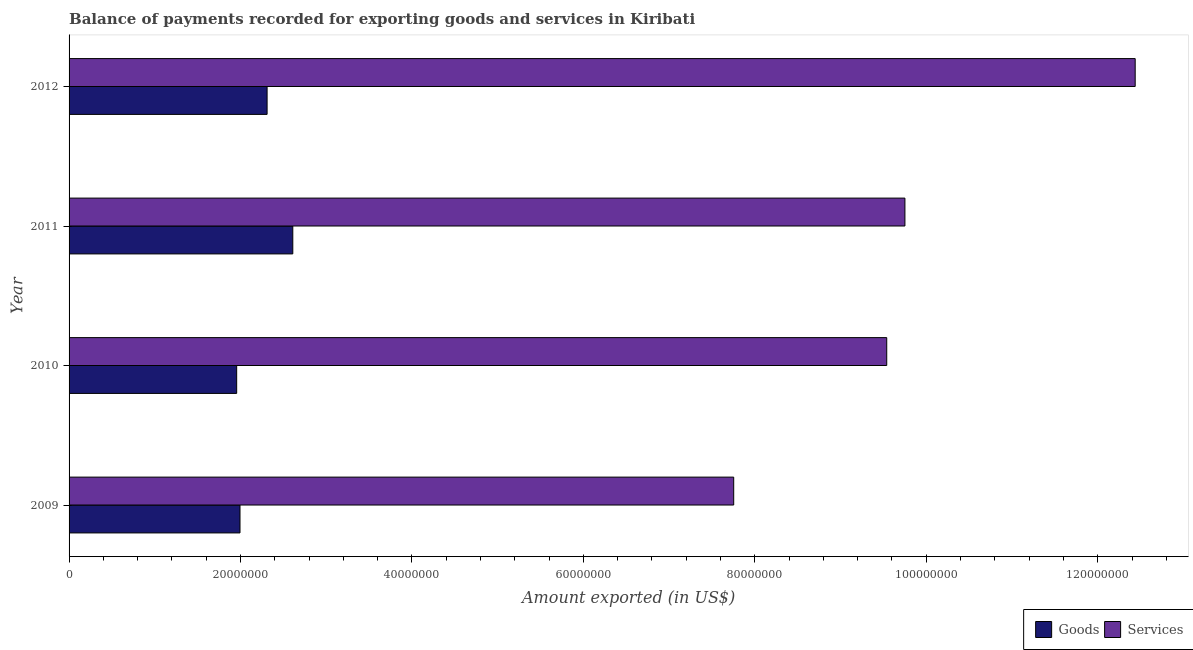Are the number of bars on each tick of the Y-axis equal?
Provide a short and direct response. Yes. How many bars are there on the 1st tick from the top?
Offer a terse response. 2. How many bars are there on the 3rd tick from the bottom?
Provide a short and direct response. 2. In how many cases, is the number of bars for a given year not equal to the number of legend labels?
Provide a short and direct response. 0. What is the amount of services exported in 2009?
Your answer should be very brief. 7.75e+07. Across all years, what is the maximum amount of services exported?
Your response must be concise. 1.24e+08. Across all years, what is the minimum amount of services exported?
Make the answer very short. 7.75e+07. In which year was the amount of services exported maximum?
Give a very brief answer. 2012. In which year was the amount of goods exported minimum?
Offer a terse response. 2010. What is the total amount of services exported in the graph?
Your response must be concise. 3.95e+08. What is the difference between the amount of services exported in 2010 and that in 2012?
Make the answer very short. -2.90e+07. What is the difference between the amount of goods exported in 2009 and the amount of services exported in 2012?
Provide a short and direct response. -1.04e+08. What is the average amount of goods exported per year?
Your response must be concise. 2.22e+07. In the year 2012, what is the difference between the amount of goods exported and amount of services exported?
Your answer should be compact. -1.01e+08. In how many years, is the amount of services exported greater than 52000000 US$?
Keep it short and to the point. 4. What is the ratio of the amount of services exported in 2009 to that in 2012?
Give a very brief answer. 0.62. What is the difference between the highest and the second highest amount of goods exported?
Make the answer very short. 3.00e+06. What is the difference between the highest and the lowest amount of goods exported?
Give a very brief answer. 6.55e+06. What does the 1st bar from the top in 2012 represents?
Keep it short and to the point. Services. What does the 1st bar from the bottom in 2012 represents?
Your answer should be very brief. Goods. Are all the bars in the graph horizontal?
Your answer should be compact. Yes. How many years are there in the graph?
Your response must be concise. 4. What is the difference between two consecutive major ticks on the X-axis?
Offer a terse response. 2.00e+07. Does the graph contain any zero values?
Provide a short and direct response. No. How are the legend labels stacked?
Keep it short and to the point. Horizontal. What is the title of the graph?
Provide a succinct answer. Balance of payments recorded for exporting goods and services in Kiribati. What is the label or title of the X-axis?
Make the answer very short. Amount exported (in US$). What is the label or title of the Y-axis?
Offer a terse response. Year. What is the Amount exported (in US$) in Goods in 2009?
Offer a terse response. 1.99e+07. What is the Amount exported (in US$) of Services in 2009?
Your answer should be compact. 7.75e+07. What is the Amount exported (in US$) of Goods in 2010?
Provide a short and direct response. 1.96e+07. What is the Amount exported (in US$) in Services in 2010?
Give a very brief answer. 9.54e+07. What is the Amount exported (in US$) of Goods in 2011?
Your response must be concise. 2.61e+07. What is the Amount exported (in US$) of Services in 2011?
Offer a terse response. 9.75e+07. What is the Amount exported (in US$) of Goods in 2012?
Your answer should be compact. 2.31e+07. What is the Amount exported (in US$) of Services in 2012?
Make the answer very short. 1.24e+08. Across all years, what is the maximum Amount exported (in US$) of Goods?
Your response must be concise. 2.61e+07. Across all years, what is the maximum Amount exported (in US$) of Services?
Keep it short and to the point. 1.24e+08. Across all years, what is the minimum Amount exported (in US$) in Goods?
Your answer should be very brief. 1.96e+07. Across all years, what is the minimum Amount exported (in US$) of Services?
Your response must be concise. 7.75e+07. What is the total Amount exported (in US$) of Goods in the graph?
Your answer should be very brief. 8.87e+07. What is the total Amount exported (in US$) of Services in the graph?
Your answer should be very brief. 3.95e+08. What is the difference between the Amount exported (in US$) in Goods in 2009 and that in 2010?
Keep it short and to the point. 3.90e+05. What is the difference between the Amount exported (in US$) of Services in 2009 and that in 2010?
Keep it short and to the point. -1.79e+07. What is the difference between the Amount exported (in US$) of Goods in 2009 and that in 2011?
Make the answer very short. -6.16e+06. What is the difference between the Amount exported (in US$) in Services in 2009 and that in 2011?
Offer a terse response. -2.00e+07. What is the difference between the Amount exported (in US$) in Goods in 2009 and that in 2012?
Ensure brevity in your answer.  -3.16e+06. What is the difference between the Amount exported (in US$) in Services in 2009 and that in 2012?
Keep it short and to the point. -4.68e+07. What is the difference between the Amount exported (in US$) in Goods in 2010 and that in 2011?
Make the answer very short. -6.55e+06. What is the difference between the Amount exported (in US$) of Services in 2010 and that in 2011?
Offer a terse response. -2.12e+06. What is the difference between the Amount exported (in US$) in Goods in 2010 and that in 2012?
Offer a very short reply. -3.55e+06. What is the difference between the Amount exported (in US$) in Services in 2010 and that in 2012?
Offer a terse response. -2.90e+07. What is the difference between the Amount exported (in US$) in Goods in 2011 and that in 2012?
Your answer should be compact. 3.00e+06. What is the difference between the Amount exported (in US$) in Services in 2011 and that in 2012?
Offer a very short reply. -2.69e+07. What is the difference between the Amount exported (in US$) of Goods in 2009 and the Amount exported (in US$) of Services in 2010?
Provide a succinct answer. -7.54e+07. What is the difference between the Amount exported (in US$) in Goods in 2009 and the Amount exported (in US$) in Services in 2011?
Offer a terse response. -7.76e+07. What is the difference between the Amount exported (in US$) in Goods in 2009 and the Amount exported (in US$) in Services in 2012?
Offer a very short reply. -1.04e+08. What is the difference between the Amount exported (in US$) of Goods in 2010 and the Amount exported (in US$) of Services in 2011?
Your answer should be compact. -7.80e+07. What is the difference between the Amount exported (in US$) of Goods in 2010 and the Amount exported (in US$) of Services in 2012?
Your answer should be compact. -1.05e+08. What is the difference between the Amount exported (in US$) in Goods in 2011 and the Amount exported (in US$) in Services in 2012?
Give a very brief answer. -9.83e+07. What is the average Amount exported (in US$) in Goods per year?
Your answer should be compact. 2.22e+07. What is the average Amount exported (in US$) in Services per year?
Give a very brief answer. 9.87e+07. In the year 2009, what is the difference between the Amount exported (in US$) in Goods and Amount exported (in US$) in Services?
Your answer should be very brief. -5.76e+07. In the year 2010, what is the difference between the Amount exported (in US$) in Goods and Amount exported (in US$) in Services?
Provide a succinct answer. -7.58e+07. In the year 2011, what is the difference between the Amount exported (in US$) of Goods and Amount exported (in US$) of Services?
Make the answer very short. -7.14e+07. In the year 2012, what is the difference between the Amount exported (in US$) in Goods and Amount exported (in US$) in Services?
Your answer should be very brief. -1.01e+08. What is the ratio of the Amount exported (in US$) in Goods in 2009 to that in 2010?
Make the answer very short. 1.02. What is the ratio of the Amount exported (in US$) of Services in 2009 to that in 2010?
Provide a short and direct response. 0.81. What is the ratio of the Amount exported (in US$) of Goods in 2009 to that in 2011?
Offer a very short reply. 0.76. What is the ratio of the Amount exported (in US$) of Services in 2009 to that in 2011?
Your answer should be very brief. 0.8. What is the ratio of the Amount exported (in US$) in Goods in 2009 to that in 2012?
Your answer should be compact. 0.86. What is the ratio of the Amount exported (in US$) in Services in 2009 to that in 2012?
Make the answer very short. 0.62. What is the ratio of the Amount exported (in US$) of Goods in 2010 to that in 2011?
Offer a terse response. 0.75. What is the ratio of the Amount exported (in US$) of Services in 2010 to that in 2011?
Ensure brevity in your answer.  0.98. What is the ratio of the Amount exported (in US$) of Goods in 2010 to that in 2012?
Keep it short and to the point. 0.85. What is the ratio of the Amount exported (in US$) of Services in 2010 to that in 2012?
Provide a succinct answer. 0.77. What is the ratio of the Amount exported (in US$) of Goods in 2011 to that in 2012?
Offer a very short reply. 1.13. What is the ratio of the Amount exported (in US$) of Services in 2011 to that in 2012?
Ensure brevity in your answer.  0.78. What is the difference between the highest and the second highest Amount exported (in US$) in Goods?
Provide a short and direct response. 3.00e+06. What is the difference between the highest and the second highest Amount exported (in US$) of Services?
Make the answer very short. 2.69e+07. What is the difference between the highest and the lowest Amount exported (in US$) in Goods?
Ensure brevity in your answer.  6.55e+06. What is the difference between the highest and the lowest Amount exported (in US$) in Services?
Offer a very short reply. 4.68e+07. 